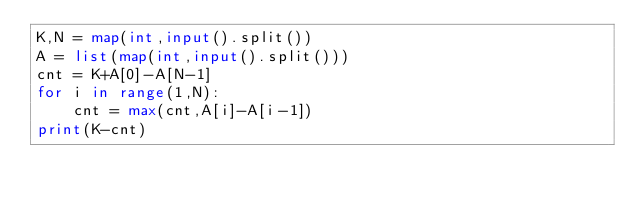Convert code to text. <code><loc_0><loc_0><loc_500><loc_500><_Python_>K,N = map(int,input().split())
A = list(map(int,input().split()))
cnt = K+A[0]-A[N-1]
for i in range(1,N):
    cnt = max(cnt,A[i]-A[i-1])
print(K-cnt)</code> 